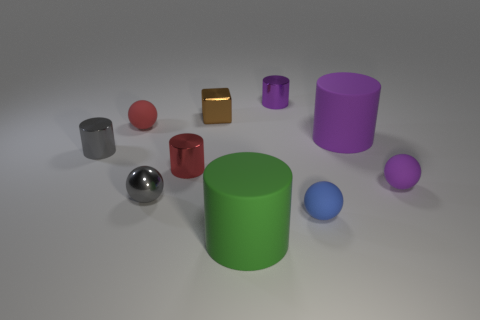Is there a brown matte sphere that has the same size as the blue thing?
Ensure brevity in your answer.  No. There is a tiny metallic cylinder on the left side of the red metal cylinder; is it the same color as the metal ball?
Your answer should be compact. Yes. What is the color of the tiny metallic cylinder that is both to the right of the tiny gray cylinder and behind the small red metal object?
Give a very brief answer. Purple. There is a purple matte object that is the same size as the block; what shape is it?
Keep it short and to the point. Sphere. Is there a tiny cyan metal object that has the same shape as the brown thing?
Make the answer very short. No. There is a purple cylinder that is behind the metallic block; is it the same size as the small blue matte thing?
Ensure brevity in your answer.  Yes. There is a purple thing that is behind the tiny red cylinder and right of the purple shiny cylinder; what is its size?
Your answer should be very brief. Large. How many other objects are there of the same material as the red cylinder?
Your answer should be very brief. 4. What size is the thing that is behind the tiny brown shiny object?
Offer a terse response. Small. What number of large objects are either green matte balls or gray things?
Offer a terse response. 0. 